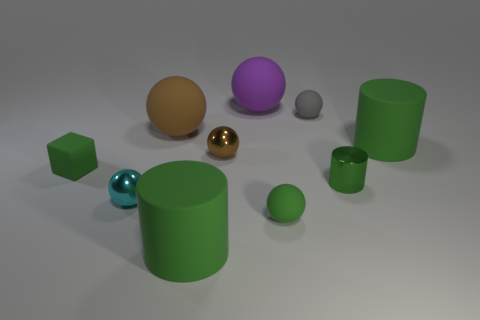Could you explain the lighting in the scene? The lighting in the scene appears to be diffuse and soft, indicated by the gentle shadows beneath the objects and the subtle highlights on their surfaces. There aren't any harsh shadows or strong, directed light sources visible, which suggests an environment with well-distributed light, possibly from multiple angles. This type of lighting helps to reveal the textures and shapes of the objects with clarity, avoiding the sharp contrasts that would come from a more direct or singular light source. 